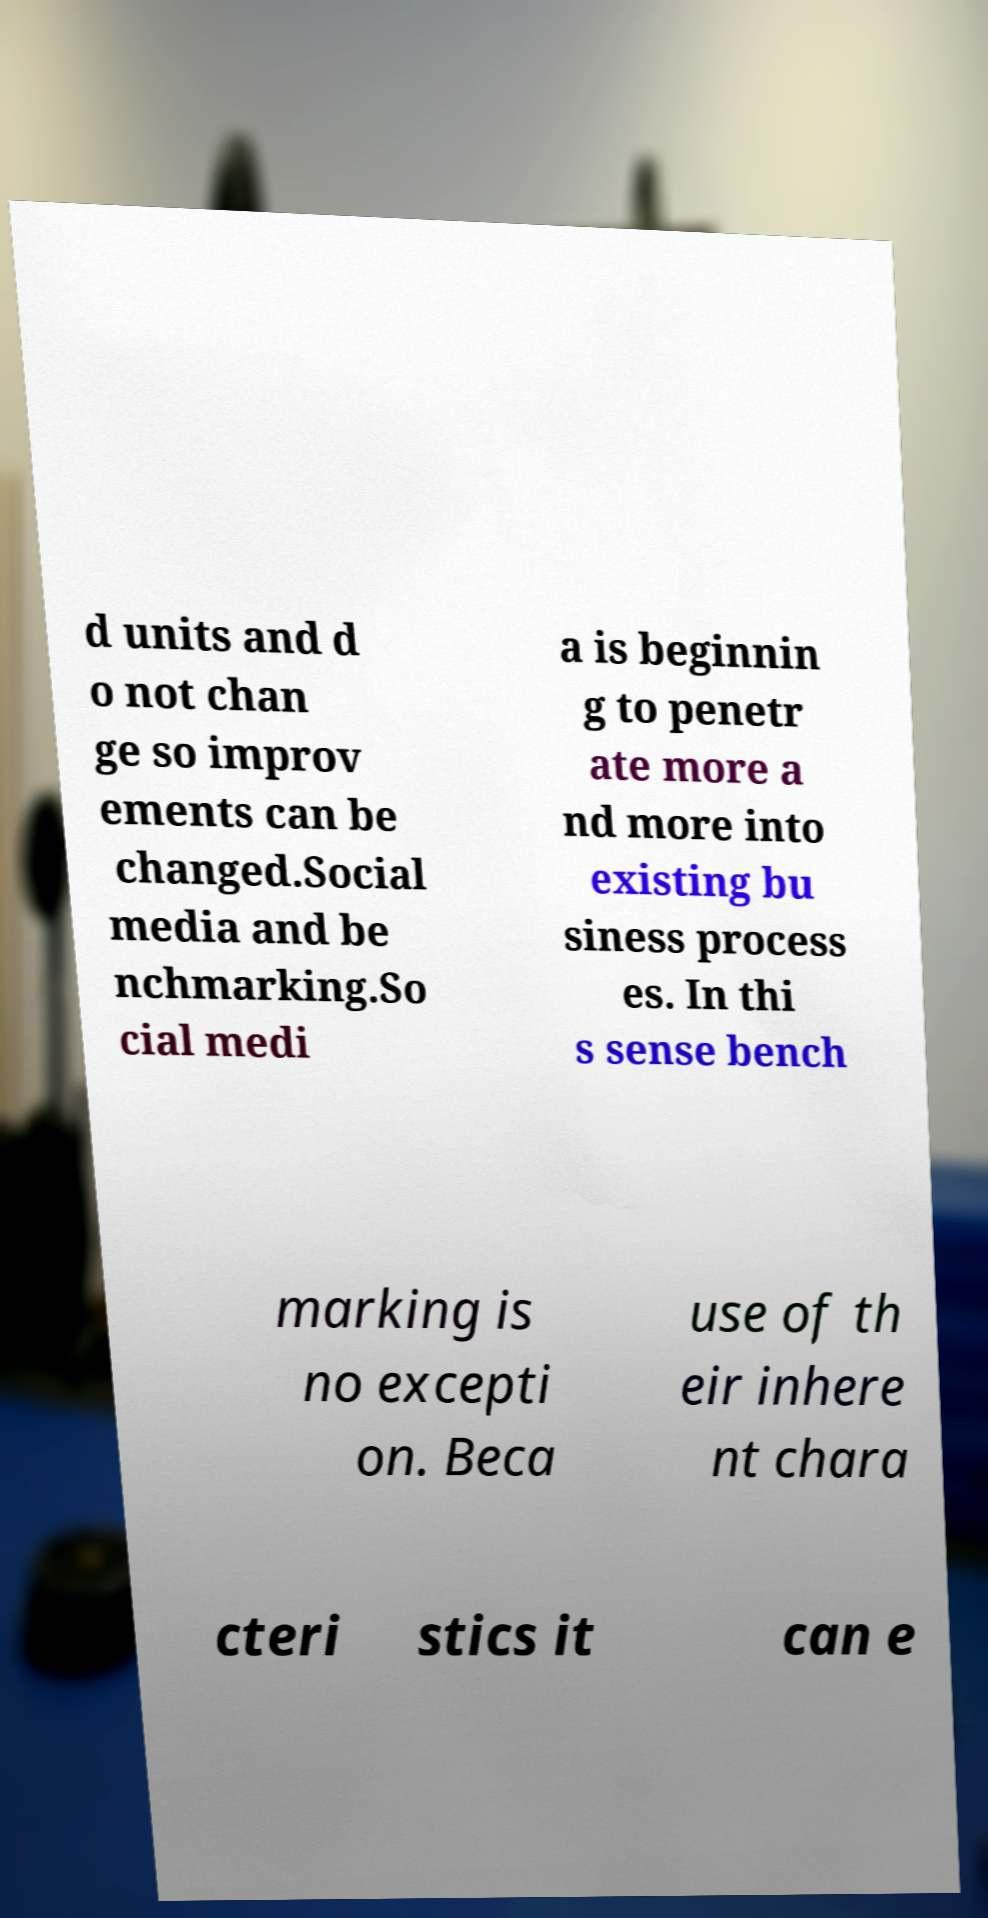Can you read and provide the text displayed in the image?This photo seems to have some interesting text. Can you extract and type it out for me? d units and d o not chan ge so improv ements can be changed.Social media and be nchmarking.So cial medi a is beginnin g to penetr ate more a nd more into existing bu siness process es. In thi s sense bench marking is no excepti on. Beca use of th eir inhere nt chara cteri stics it can e 